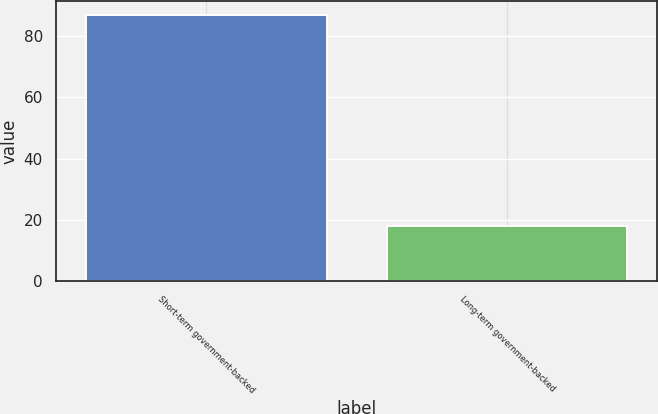<chart> <loc_0><loc_0><loc_500><loc_500><bar_chart><fcel>Short-term government-backed<fcel>Long-term government-backed<nl><fcel>87<fcel>18<nl></chart> 